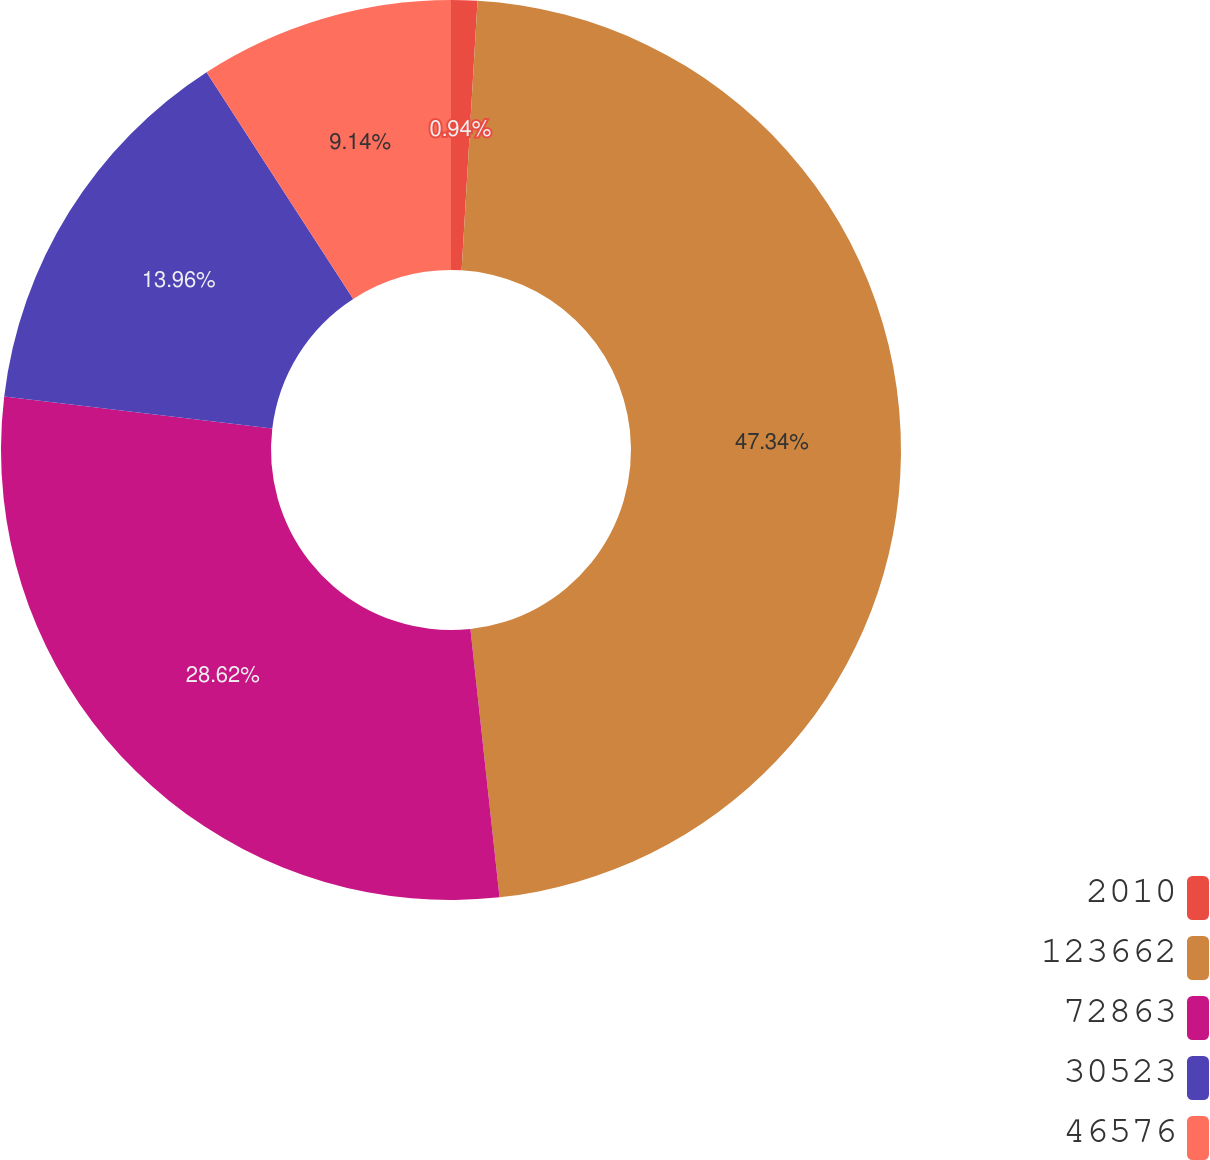<chart> <loc_0><loc_0><loc_500><loc_500><pie_chart><fcel>2010<fcel>123662<fcel>72863<fcel>30523<fcel>46576<nl><fcel>0.94%<fcel>47.34%<fcel>28.62%<fcel>13.96%<fcel>9.14%<nl></chart> 